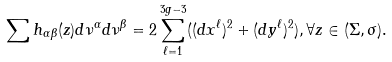<formula> <loc_0><loc_0><loc_500><loc_500>\sum h _ { \alpha \beta } ( z ) d \nu ^ { \alpha } d \nu ^ { \beta } = 2 \sum _ { \ell = 1 } ^ { 3 g - 3 } ( ( d x ^ { \ell } ) ^ { 2 } + ( d y ^ { \ell } ) ^ { 2 } ) , \forall z \in ( \Sigma , \sigma ) .</formula> 